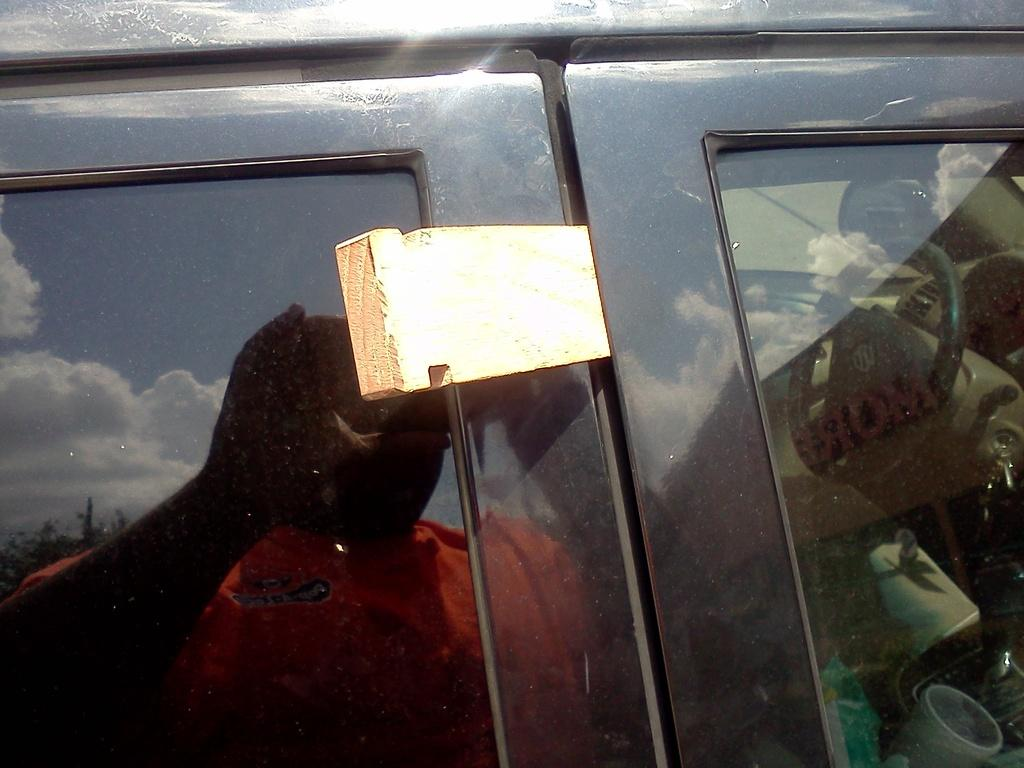What is the main subject of the picture? The main subject of the picture is a vehicle. What features can be observed on the vehicle? The vehicle has windows and a visible steering wheel. Can you describe the person visible through the vehicle windows? Unfortunately, the person's appearance cannot be described in detail from the image. What type of natural elements are present in the image? There are trees and clouds visible in the image. What else can be seen in the image besides the vehicle and natural elements? There are objects visible in the image. What word is being used to cause a commotion in the club depicted in the image? There is no club or commotion present in the image; it features a vehicle with a person visible through the windows. 